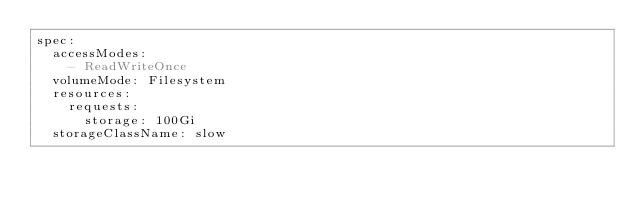<code> <loc_0><loc_0><loc_500><loc_500><_YAML_>spec:
  accessModes:
    - ReadWriteOnce
  volumeMode: Filesystem
  resources:
    requests:
      storage: 100Gi
  storageClassName: slow
</code> 